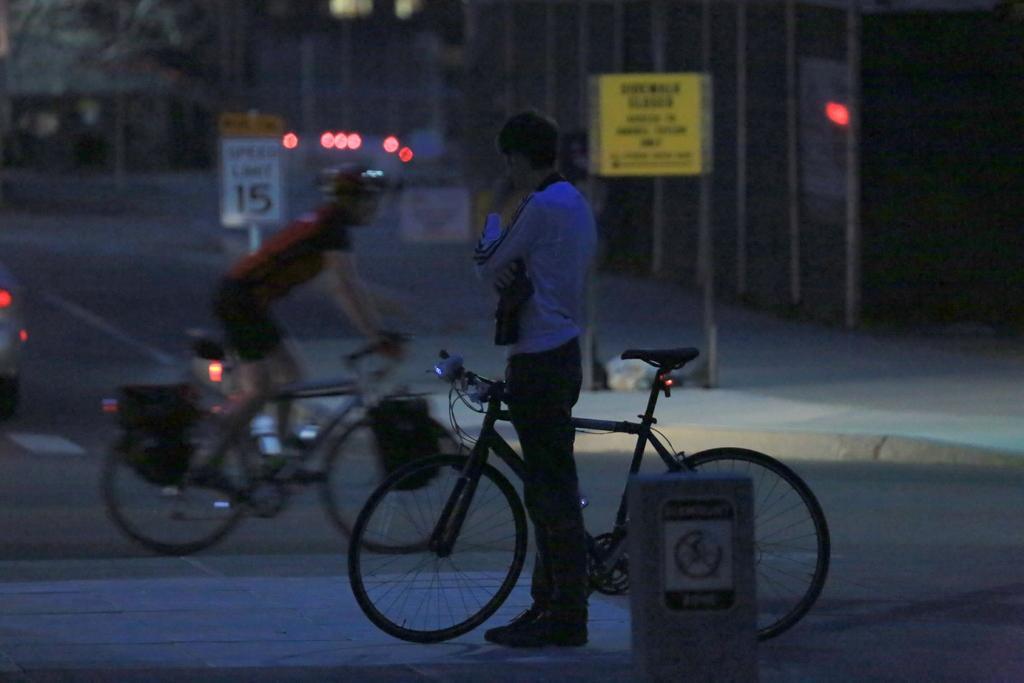How would you summarize this image in a sentence or two? In this image i can see a there are the two persons standing on the floor and there a person wearing a red color t-shirt riding a bi cycle on the road. And there is a sign board visible on the middle. 